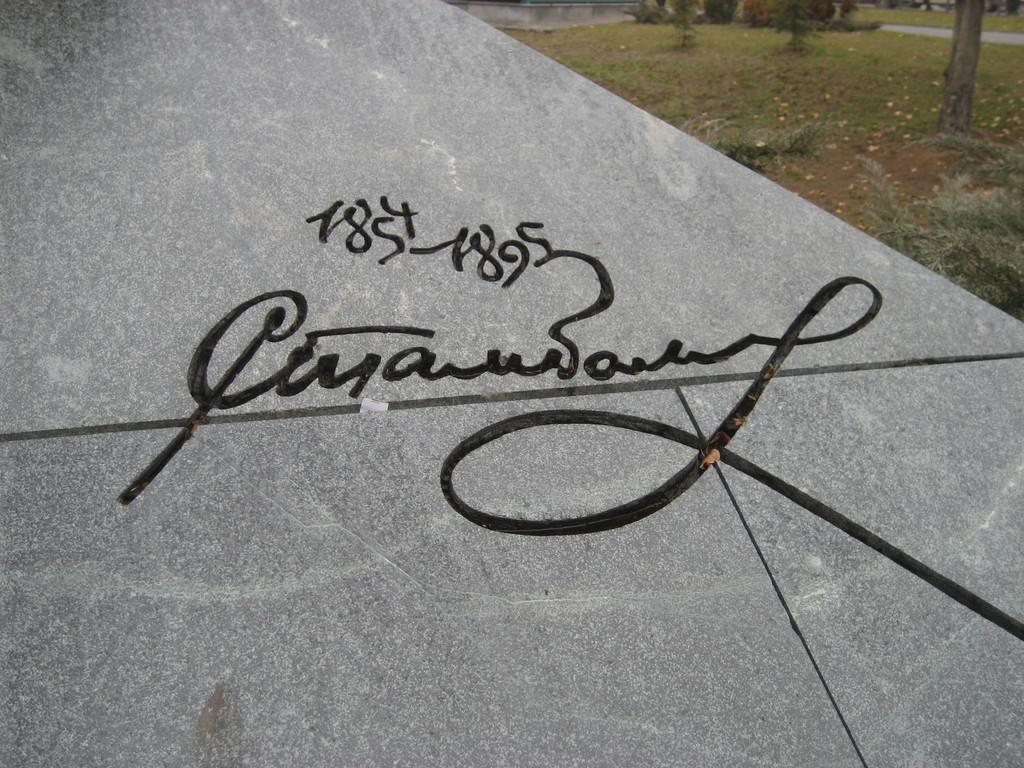What is the main object in the center of the image? There is a board in the center of the image. What can be seen on the board? There is text on the board. What type of natural environment is visible in the background of the image? There is grass and trees in the background of the image. What type of lunch is being served on the train in the image? There is no train or lunch present in the image; it features a board with text and a natural background. What account number is associated with the board in the image? There is no account number mentioned or associated with the board in the image. 